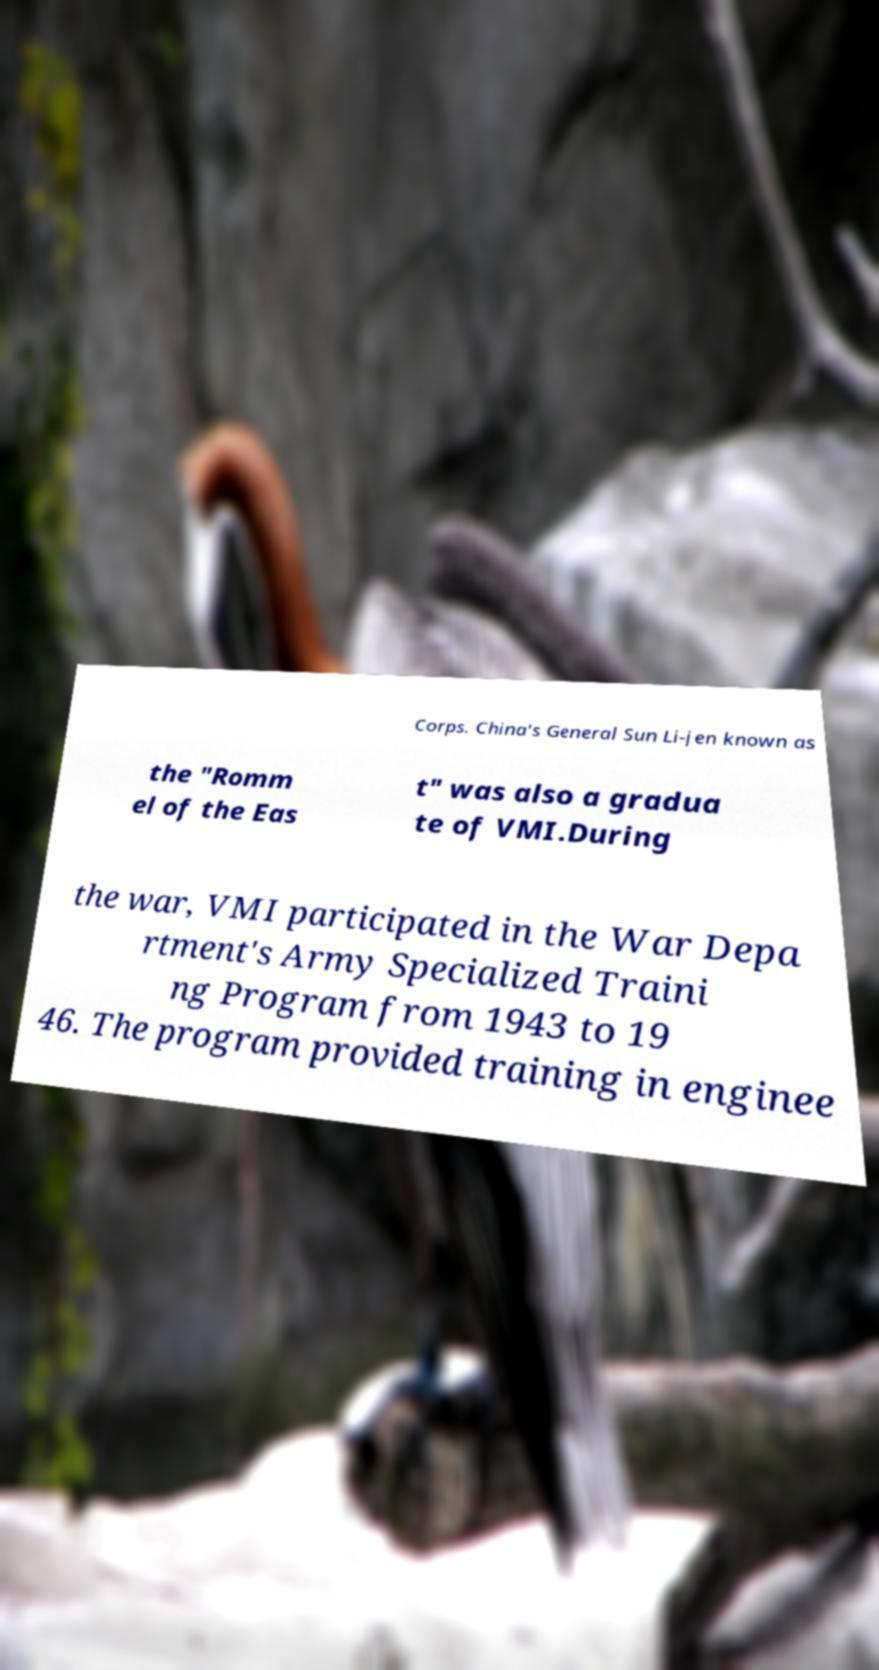Can you accurately transcribe the text from the provided image for me? Corps. China's General Sun Li-jen known as the "Romm el of the Eas t" was also a gradua te of VMI.During the war, VMI participated in the War Depa rtment's Army Specialized Traini ng Program from 1943 to 19 46. The program provided training in enginee 